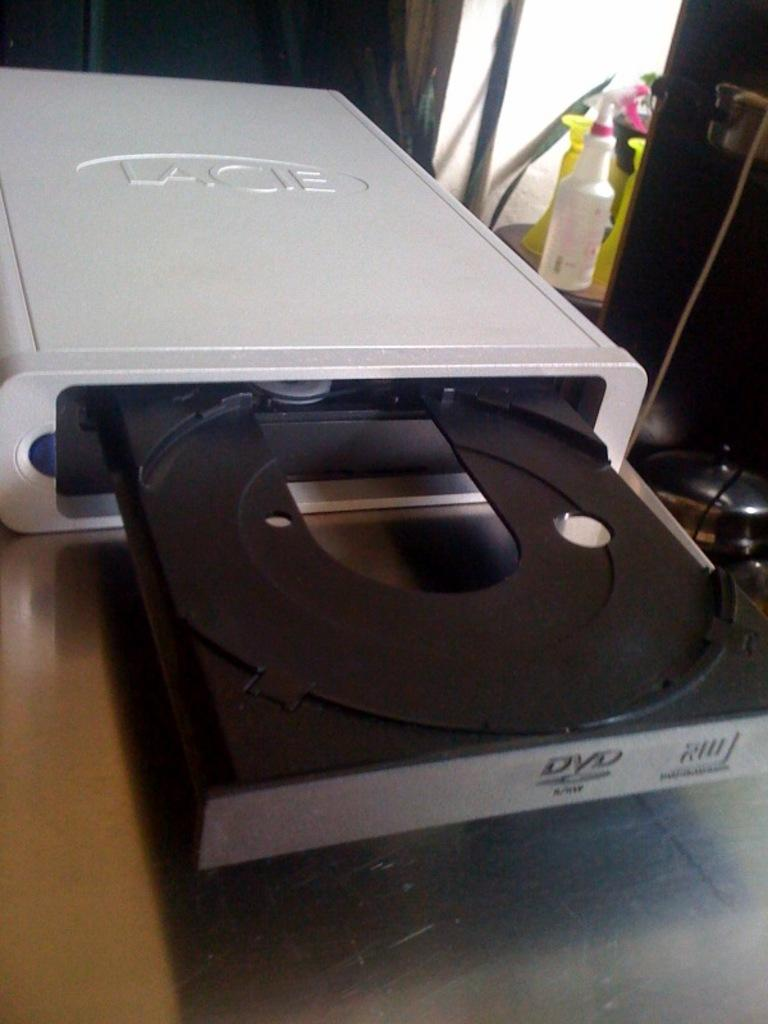What electronic device is present on the table in the image? There is a DVD player on a table in the image. Can you describe any other objects in the background of the image? Yes, there are spray bottles on the floor in the background of the image. What type of flower is being celebrated on the birthday in the image? There is no flower or birthday celebration present in the image. 